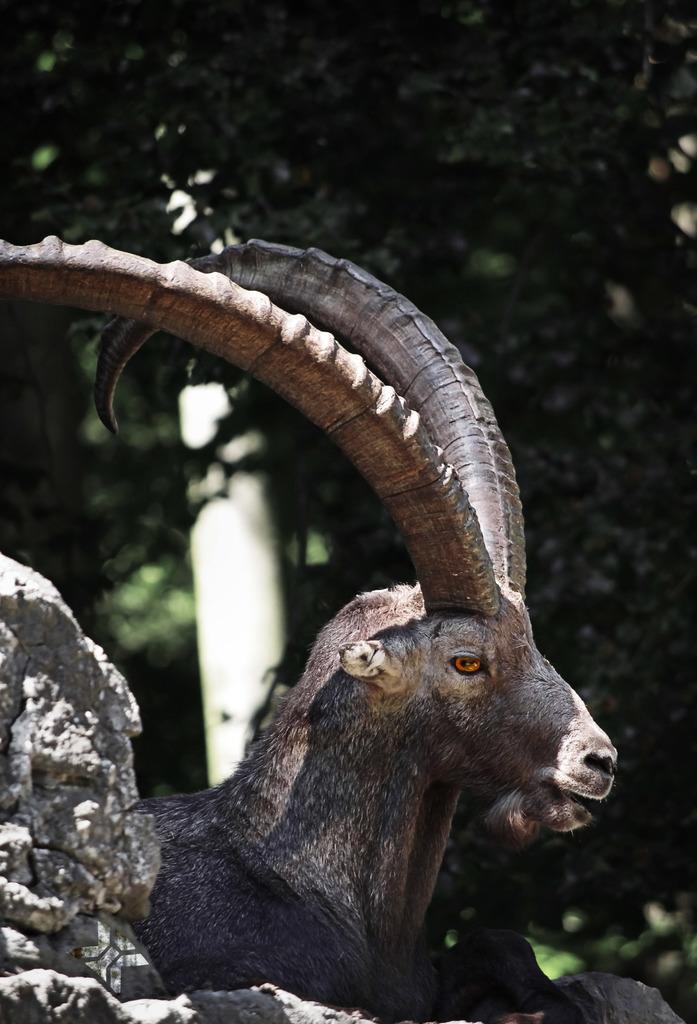Describe this image in one or two sentences. In this image we can see an animal and there is a rock and in the background, we can see few trees and there is an object which looks like a pole. 